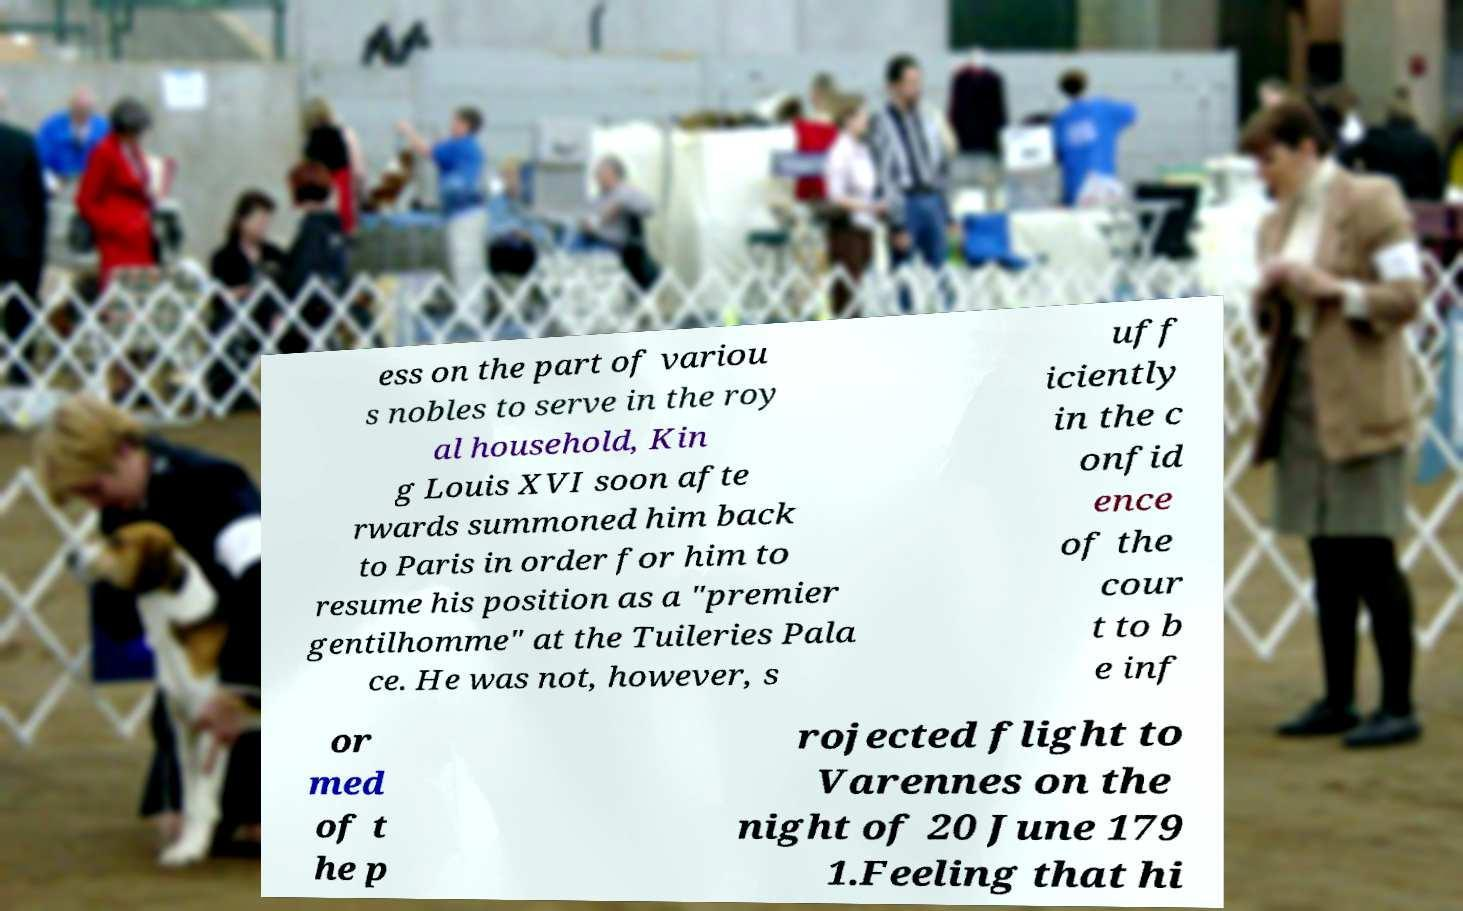What messages or text are displayed in this image? I need them in a readable, typed format. ess on the part of variou s nobles to serve in the roy al household, Kin g Louis XVI soon afte rwards summoned him back to Paris in order for him to resume his position as a "premier gentilhomme" at the Tuileries Pala ce. He was not, however, s uff iciently in the c onfid ence of the cour t to b e inf or med of t he p rojected flight to Varennes on the night of 20 June 179 1.Feeling that hi 